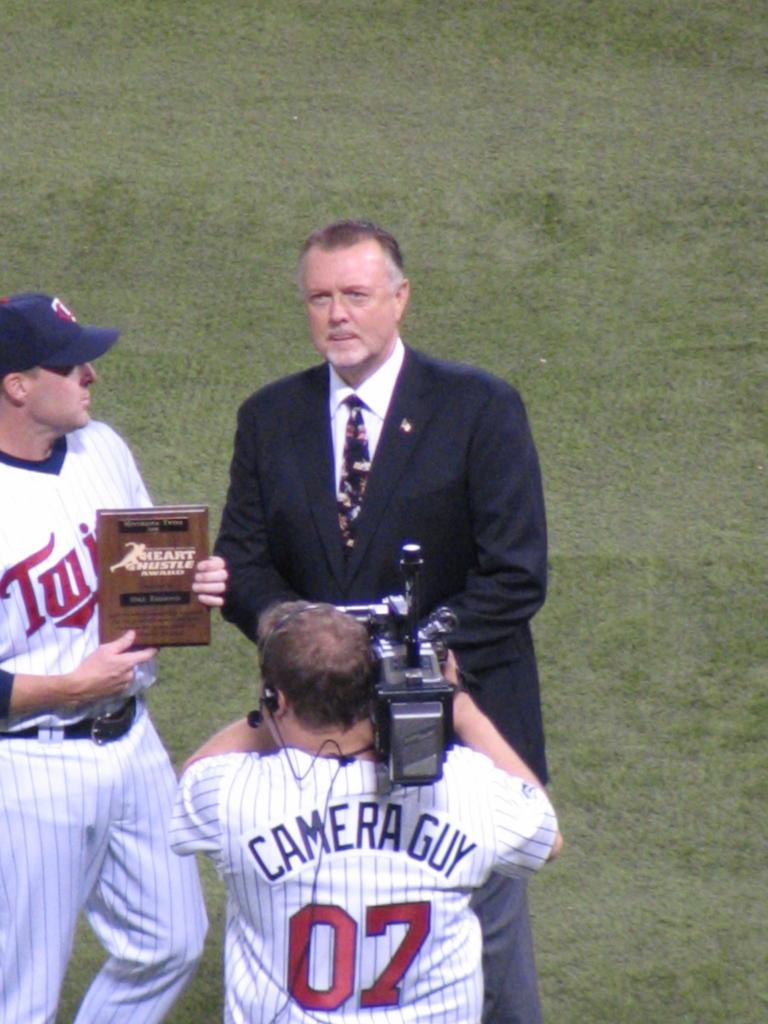<image>
Create a compact narrative representing the image presented. Camera Guy 07 wears a jersey like the team as he video types someone. 